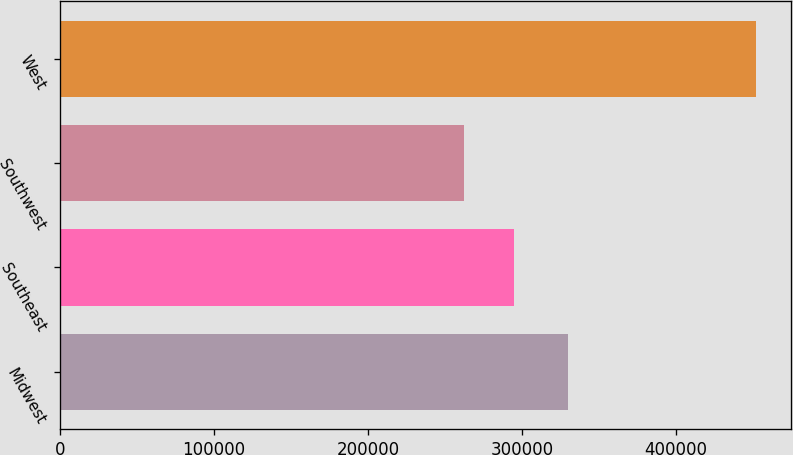Convert chart to OTSL. <chart><loc_0><loc_0><loc_500><loc_500><bar_chart><fcel>Midwest<fcel>Southeast<fcel>Southwest<fcel>West<nl><fcel>330000<fcel>295100<fcel>262600<fcel>452300<nl></chart> 